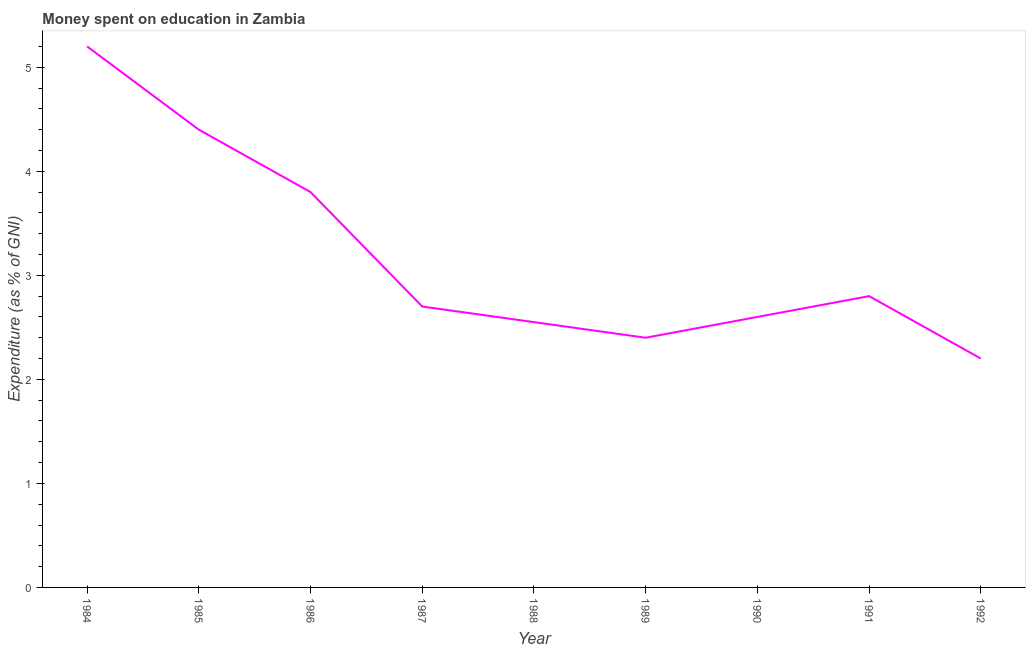Across all years, what is the minimum expenditure on education?
Your answer should be very brief. 2.2. What is the sum of the expenditure on education?
Provide a succinct answer. 28.65. What is the difference between the expenditure on education in 1984 and 1986?
Provide a succinct answer. 1.4. What is the average expenditure on education per year?
Your answer should be very brief. 3.18. In how many years, is the expenditure on education greater than 4.6 %?
Provide a short and direct response. 1. What is the ratio of the expenditure on education in 1985 to that in 1991?
Your response must be concise. 1.57. Is the expenditure on education in 1986 less than that in 1990?
Offer a terse response. No. What is the difference between the highest and the second highest expenditure on education?
Offer a terse response. 0.8. Is the sum of the expenditure on education in 1984 and 1989 greater than the maximum expenditure on education across all years?
Ensure brevity in your answer.  Yes. What is the difference between the highest and the lowest expenditure on education?
Your answer should be very brief. 3. Does the expenditure on education monotonically increase over the years?
Offer a terse response. No. What is the difference between two consecutive major ticks on the Y-axis?
Offer a very short reply. 1. Are the values on the major ticks of Y-axis written in scientific E-notation?
Make the answer very short. No. What is the title of the graph?
Offer a very short reply. Money spent on education in Zambia. What is the label or title of the Y-axis?
Keep it short and to the point. Expenditure (as % of GNI). What is the Expenditure (as % of GNI) in 1984?
Your answer should be very brief. 5.2. What is the Expenditure (as % of GNI) in 1985?
Provide a short and direct response. 4.4. What is the Expenditure (as % of GNI) of 1988?
Your answer should be compact. 2.55. What is the Expenditure (as % of GNI) of 1990?
Give a very brief answer. 2.6. What is the Expenditure (as % of GNI) of 1992?
Keep it short and to the point. 2.2. What is the difference between the Expenditure (as % of GNI) in 1984 and 1985?
Keep it short and to the point. 0.8. What is the difference between the Expenditure (as % of GNI) in 1984 and 1986?
Ensure brevity in your answer.  1.4. What is the difference between the Expenditure (as % of GNI) in 1984 and 1987?
Offer a terse response. 2.5. What is the difference between the Expenditure (as % of GNI) in 1984 and 1988?
Provide a short and direct response. 2.65. What is the difference between the Expenditure (as % of GNI) in 1984 and 1989?
Provide a succinct answer. 2.8. What is the difference between the Expenditure (as % of GNI) in 1984 and 1990?
Make the answer very short. 2.6. What is the difference between the Expenditure (as % of GNI) in 1984 and 1991?
Your answer should be very brief. 2.4. What is the difference between the Expenditure (as % of GNI) in 1984 and 1992?
Keep it short and to the point. 3. What is the difference between the Expenditure (as % of GNI) in 1985 and 1986?
Offer a very short reply. 0.6. What is the difference between the Expenditure (as % of GNI) in 1985 and 1987?
Provide a short and direct response. 1.7. What is the difference between the Expenditure (as % of GNI) in 1985 and 1988?
Your answer should be compact. 1.85. What is the difference between the Expenditure (as % of GNI) in 1985 and 1990?
Give a very brief answer. 1.8. What is the difference between the Expenditure (as % of GNI) in 1985 and 1992?
Keep it short and to the point. 2.2. What is the difference between the Expenditure (as % of GNI) in 1986 and 1988?
Ensure brevity in your answer.  1.25. What is the difference between the Expenditure (as % of GNI) in 1986 and 1990?
Ensure brevity in your answer.  1.2. What is the difference between the Expenditure (as % of GNI) in 1987 and 1988?
Ensure brevity in your answer.  0.15. What is the difference between the Expenditure (as % of GNI) in 1987 and 1991?
Your response must be concise. -0.1. What is the difference between the Expenditure (as % of GNI) in 1988 and 1991?
Offer a terse response. -0.25. What is the difference between the Expenditure (as % of GNI) in 1988 and 1992?
Make the answer very short. 0.35. What is the difference between the Expenditure (as % of GNI) in 1989 and 1990?
Ensure brevity in your answer.  -0.2. What is the difference between the Expenditure (as % of GNI) in 1990 and 1991?
Provide a short and direct response. -0.2. What is the difference between the Expenditure (as % of GNI) in 1990 and 1992?
Your answer should be compact. 0.4. What is the ratio of the Expenditure (as % of GNI) in 1984 to that in 1985?
Provide a short and direct response. 1.18. What is the ratio of the Expenditure (as % of GNI) in 1984 to that in 1986?
Your response must be concise. 1.37. What is the ratio of the Expenditure (as % of GNI) in 1984 to that in 1987?
Your answer should be compact. 1.93. What is the ratio of the Expenditure (as % of GNI) in 1984 to that in 1988?
Keep it short and to the point. 2.04. What is the ratio of the Expenditure (as % of GNI) in 1984 to that in 1989?
Provide a succinct answer. 2.17. What is the ratio of the Expenditure (as % of GNI) in 1984 to that in 1990?
Make the answer very short. 2. What is the ratio of the Expenditure (as % of GNI) in 1984 to that in 1991?
Your answer should be compact. 1.86. What is the ratio of the Expenditure (as % of GNI) in 1984 to that in 1992?
Give a very brief answer. 2.36. What is the ratio of the Expenditure (as % of GNI) in 1985 to that in 1986?
Your answer should be compact. 1.16. What is the ratio of the Expenditure (as % of GNI) in 1985 to that in 1987?
Your response must be concise. 1.63. What is the ratio of the Expenditure (as % of GNI) in 1985 to that in 1988?
Your answer should be very brief. 1.73. What is the ratio of the Expenditure (as % of GNI) in 1985 to that in 1989?
Your response must be concise. 1.83. What is the ratio of the Expenditure (as % of GNI) in 1985 to that in 1990?
Provide a succinct answer. 1.69. What is the ratio of the Expenditure (as % of GNI) in 1985 to that in 1991?
Keep it short and to the point. 1.57. What is the ratio of the Expenditure (as % of GNI) in 1986 to that in 1987?
Provide a short and direct response. 1.41. What is the ratio of the Expenditure (as % of GNI) in 1986 to that in 1988?
Offer a terse response. 1.49. What is the ratio of the Expenditure (as % of GNI) in 1986 to that in 1989?
Ensure brevity in your answer.  1.58. What is the ratio of the Expenditure (as % of GNI) in 1986 to that in 1990?
Ensure brevity in your answer.  1.46. What is the ratio of the Expenditure (as % of GNI) in 1986 to that in 1991?
Give a very brief answer. 1.36. What is the ratio of the Expenditure (as % of GNI) in 1986 to that in 1992?
Your answer should be very brief. 1.73. What is the ratio of the Expenditure (as % of GNI) in 1987 to that in 1988?
Ensure brevity in your answer.  1.06. What is the ratio of the Expenditure (as % of GNI) in 1987 to that in 1989?
Provide a succinct answer. 1.12. What is the ratio of the Expenditure (as % of GNI) in 1987 to that in 1990?
Give a very brief answer. 1.04. What is the ratio of the Expenditure (as % of GNI) in 1987 to that in 1991?
Your answer should be very brief. 0.96. What is the ratio of the Expenditure (as % of GNI) in 1987 to that in 1992?
Make the answer very short. 1.23. What is the ratio of the Expenditure (as % of GNI) in 1988 to that in 1989?
Your response must be concise. 1.06. What is the ratio of the Expenditure (as % of GNI) in 1988 to that in 1990?
Your answer should be compact. 0.98. What is the ratio of the Expenditure (as % of GNI) in 1988 to that in 1991?
Keep it short and to the point. 0.91. What is the ratio of the Expenditure (as % of GNI) in 1988 to that in 1992?
Your answer should be very brief. 1.16. What is the ratio of the Expenditure (as % of GNI) in 1989 to that in 1990?
Your response must be concise. 0.92. What is the ratio of the Expenditure (as % of GNI) in 1989 to that in 1991?
Your response must be concise. 0.86. What is the ratio of the Expenditure (as % of GNI) in 1989 to that in 1992?
Keep it short and to the point. 1.09. What is the ratio of the Expenditure (as % of GNI) in 1990 to that in 1991?
Give a very brief answer. 0.93. What is the ratio of the Expenditure (as % of GNI) in 1990 to that in 1992?
Your response must be concise. 1.18. What is the ratio of the Expenditure (as % of GNI) in 1991 to that in 1992?
Ensure brevity in your answer.  1.27. 